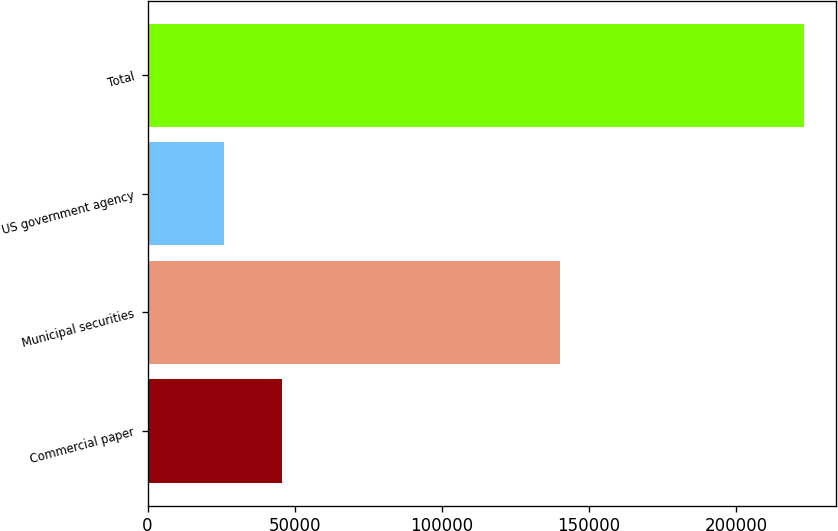Convert chart to OTSL. <chart><loc_0><loc_0><loc_500><loc_500><bar_chart><fcel>Commercial paper<fcel>Municipal securities<fcel>US government agency<fcel>Total<nl><fcel>45740.7<fcel>140198<fcel>26051<fcel>222948<nl></chart> 